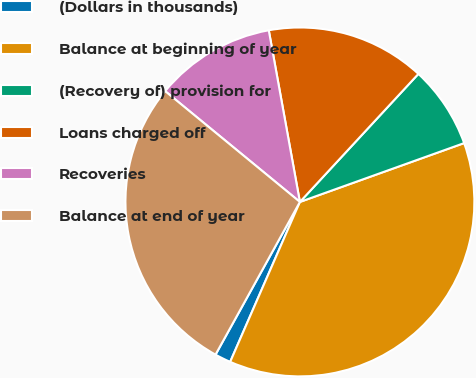<chart> <loc_0><loc_0><loc_500><loc_500><pie_chart><fcel>(Dollars in thousands)<fcel>Balance at beginning of year<fcel>(Recovery of) provision for<fcel>Loans charged off<fcel>Recoveries<fcel>Balance at end of year<nl><fcel>1.49%<fcel>37.02%<fcel>7.64%<fcel>14.74%<fcel>11.19%<fcel>27.92%<nl></chart> 